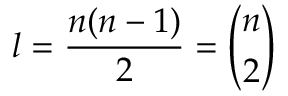<formula> <loc_0><loc_0><loc_500><loc_500>l = { \frac { n ( n - 1 ) } { 2 } } = { \binom { n } { 2 } }</formula> 